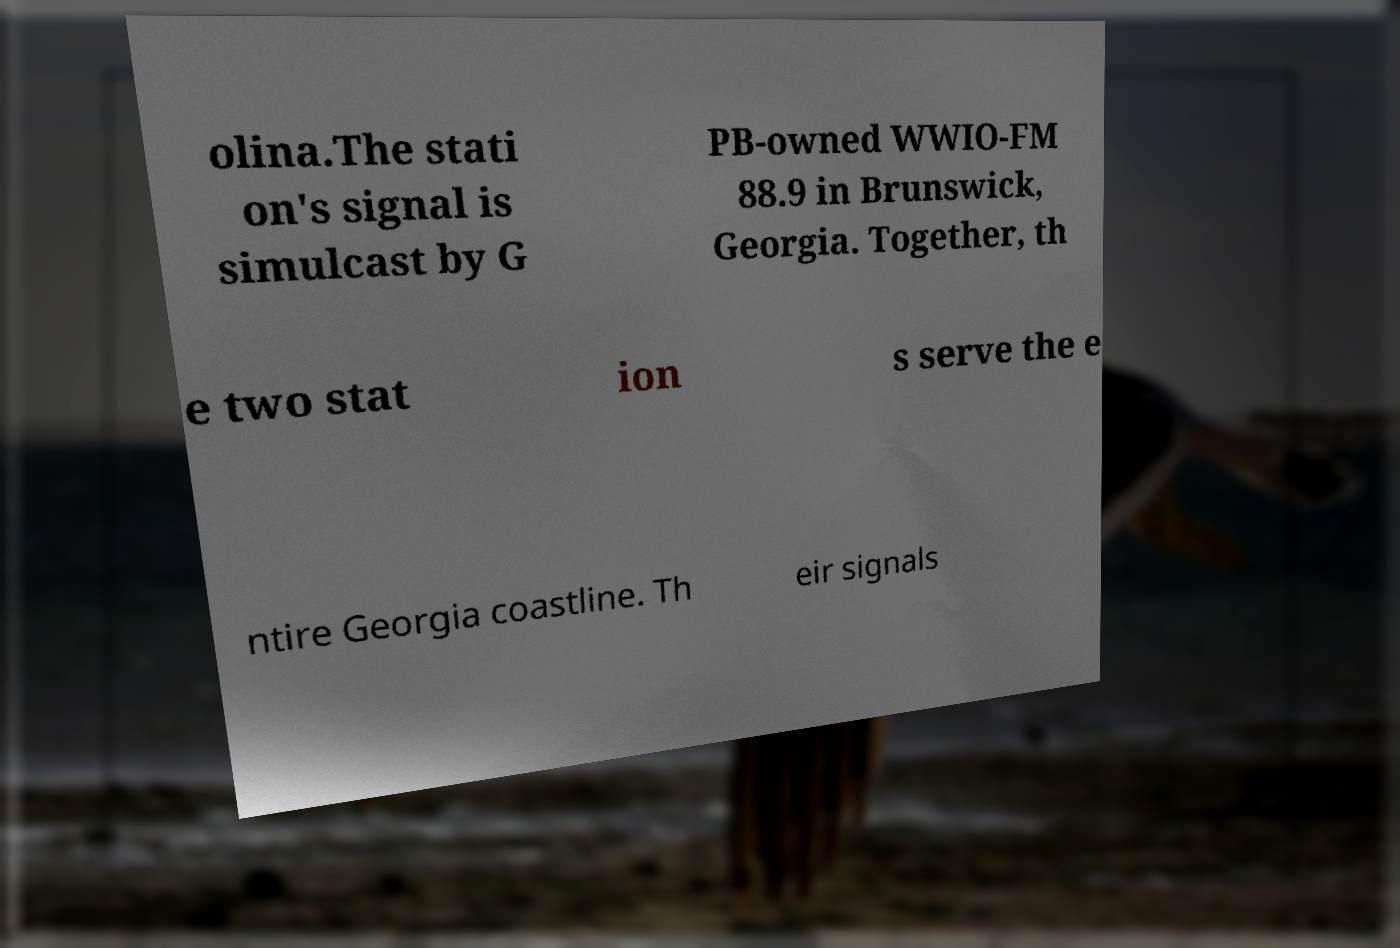Please identify and transcribe the text found in this image. olina.The stati on's signal is simulcast by G PB-owned WWIO-FM 88.9 in Brunswick, Georgia. Together, th e two stat ion s serve the e ntire Georgia coastline. Th eir signals 